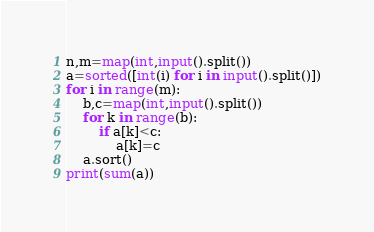<code> <loc_0><loc_0><loc_500><loc_500><_Python_>n,m=map(int,input().split())
a=sorted([int(i) for i in input().split()])
for i in range(m):
    b,c=map(int,input().split())
    for k in range(b):
        if a[k]<c:
            a[k]=c
    a.sort()
print(sum(a))
</code> 